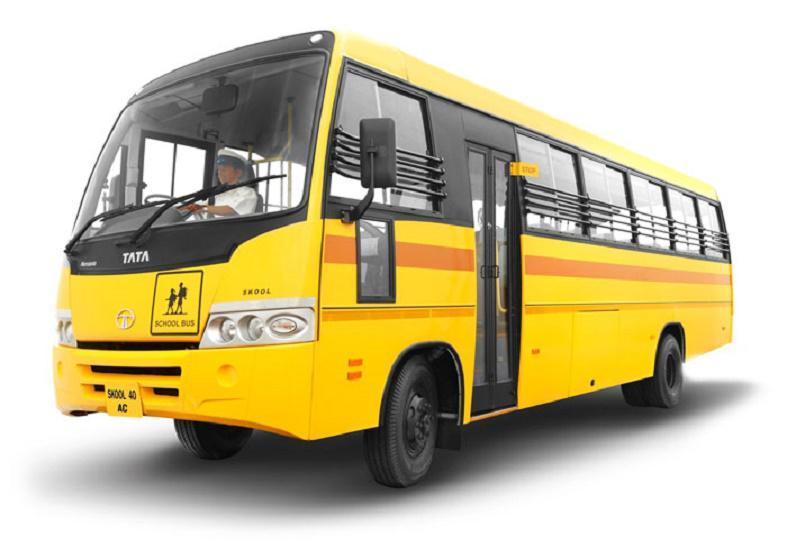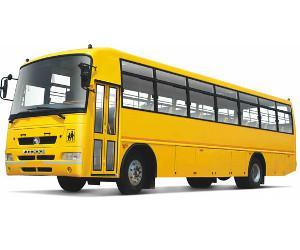The first image is the image on the left, the second image is the image on the right. Analyze the images presented: Is the assertion "The buses in the left and right images face leftward, and neither bus has a driver behind the wheel." valid? Answer yes or no. No. The first image is the image on the left, the second image is the image on the right. Examine the images to the left and right. Is the description "Two school buses are angled in the same direction, one with side double doors behind the front tire, and the other with double doors in front of the tire." accurate? Answer yes or no. Yes. 